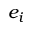Convert formula to latex. <formula><loc_0><loc_0><loc_500><loc_500>e _ { i }</formula> 